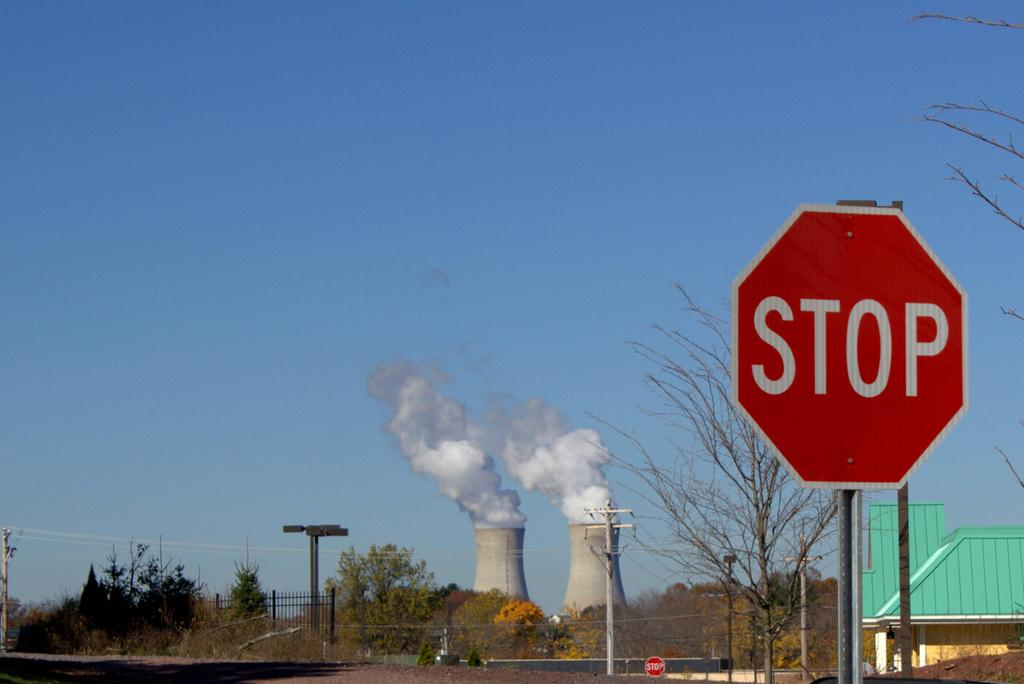<image>
Give a short and clear explanation of the subsequent image. The cooling towers of the nuclear power plant loomed over the town. 